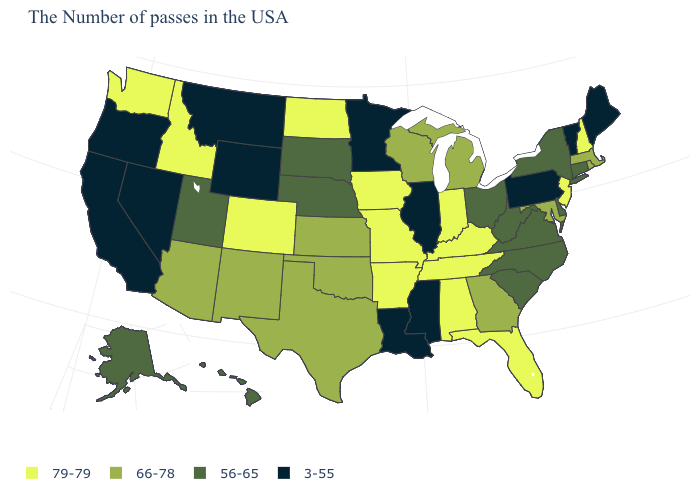What is the highest value in the USA?
Give a very brief answer. 79-79. What is the value of Alaska?
Quick response, please. 56-65. Does the map have missing data?
Answer briefly. No. Among the states that border Maine , which have the lowest value?
Short answer required. New Hampshire. How many symbols are there in the legend?
Keep it brief. 4. What is the value of Delaware?
Answer briefly. 56-65. Which states have the highest value in the USA?
Write a very short answer. New Hampshire, New Jersey, Florida, Kentucky, Indiana, Alabama, Tennessee, Missouri, Arkansas, Iowa, North Dakota, Colorado, Idaho, Washington. What is the highest value in states that border Louisiana?
Quick response, please. 79-79. Does Nevada have the lowest value in the USA?
Quick response, please. Yes. How many symbols are there in the legend?
Short answer required. 4. Does North Carolina have the highest value in the South?
Be succinct. No. What is the value of Delaware?
Short answer required. 56-65. What is the lowest value in the MidWest?
Answer briefly. 3-55. What is the value of Connecticut?
Concise answer only. 56-65. Does Georgia have the lowest value in the South?
Answer briefly. No. 